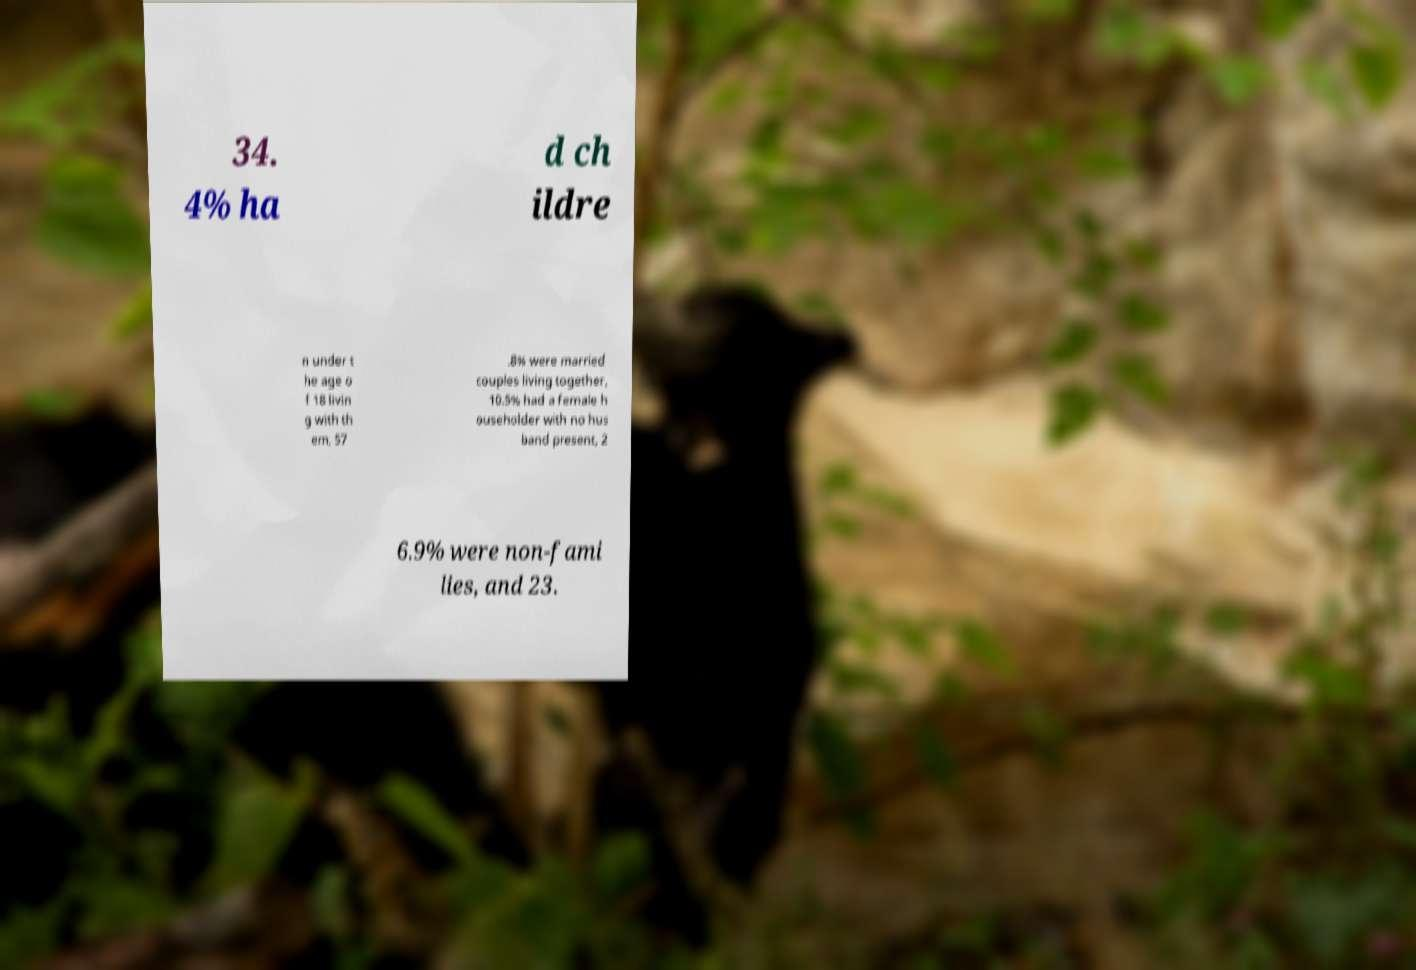What messages or text are displayed in this image? I need them in a readable, typed format. 34. 4% ha d ch ildre n under t he age o f 18 livin g with th em, 57 .8% were married couples living together, 10.5% had a female h ouseholder with no hus band present, 2 6.9% were non-fami lies, and 23. 